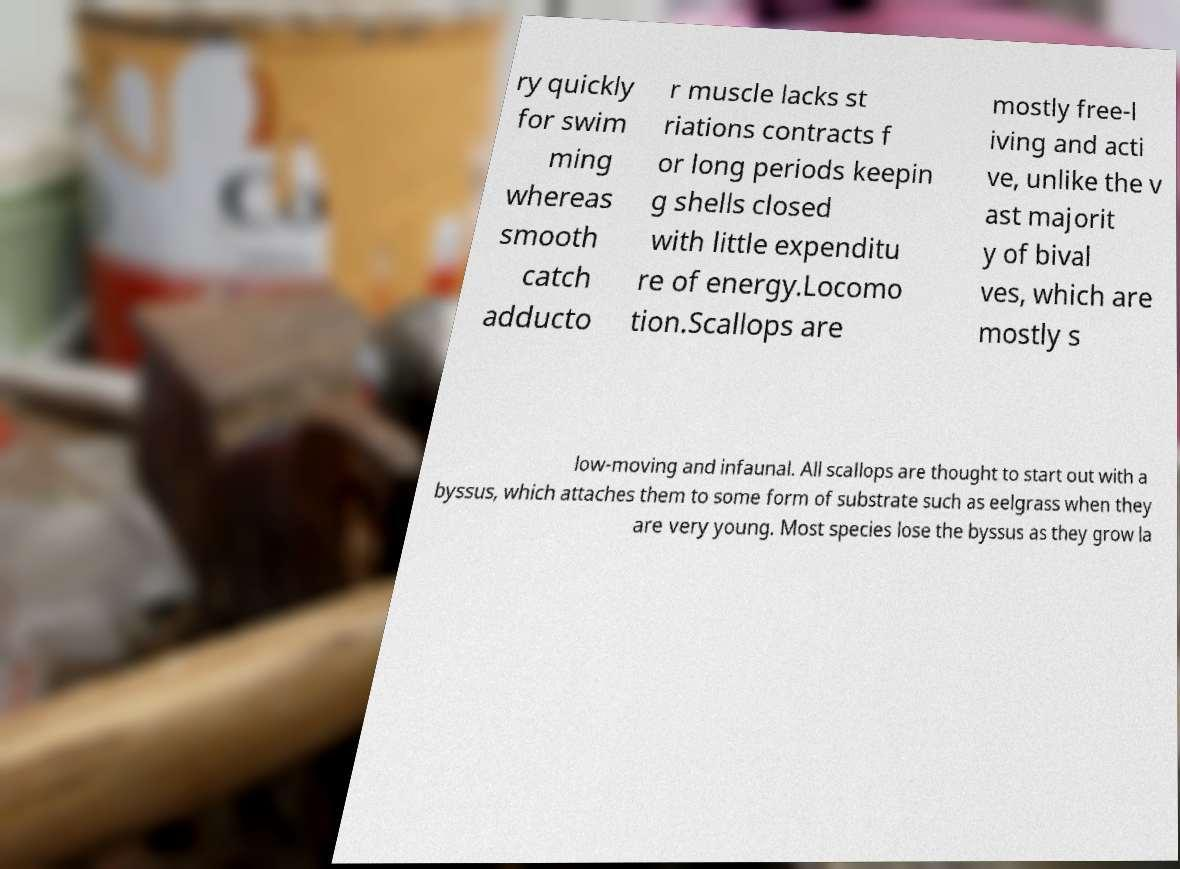There's text embedded in this image that I need extracted. Can you transcribe it verbatim? ry quickly for swim ming whereas smooth catch adducto r muscle lacks st riations contracts f or long periods keepin g shells closed with little expenditu re of energy.Locomo tion.Scallops are mostly free-l iving and acti ve, unlike the v ast majorit y of bival ves, which are mostly s low-moving and infaunal. All scallops are thought to start out with a byssus, which attaches them to some form of substrate such as eelgrass when they are very young. Most species lose the byssus as they grow la 